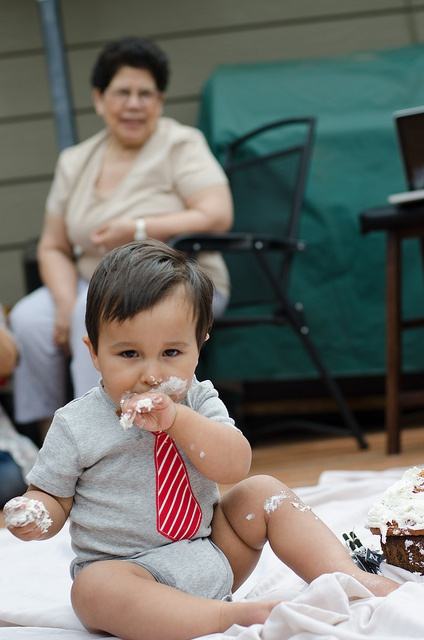Describe the objects in this image and their specific colors. I can see people in black, darkgray, gray, and tan tones, people in black, darkgray, tan, lightgray, and gray tones, chair in black, teal, and purple tones, dining table in black, teal, and maroon tones, and cake in black, white, maroon, and darkgray tones in this image. 